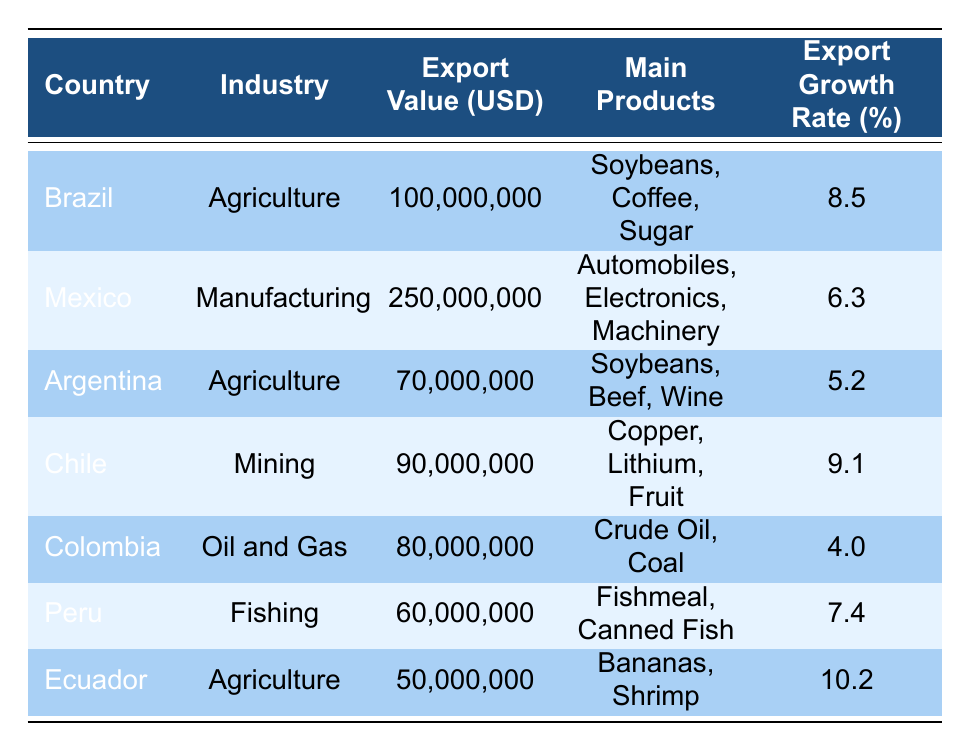What is the highest export value among the countries listed? The highest export value can be found by comparing the "Export Value (USD)" column of all countries. The highest value is 250,000,000, associated with Mexico.
Answer: 250,000,000 Which country's export growth rate is the lowest? The export growth rates are 8.5 (Brazil), 6.3 (Mexico), 5.2 (Argentina), 9.1 (Chile), 4.0 (Colombia), 7.4 (Peru), and 10.2 (Ecuador). Comparing these rates, Colombia has the lowest at 4.0%.
Answer: 4.0 What is the total export value of the Agriculture industry across all countries? To find the total export value of the Agriculture industry, we sum the export values of Brazil (100,000,000), Argentina (70,000,000), and Ecuador (50,000,000): 100,000,000 + 70,000,000 + 50,000,000 = 220,000,000.
Answer: 220,000,000 Do any countries export more than 70 million USD in Fishing industry? The table shows only Peru under the Fishing industry with an export value of 60,000,000. Since no other country exports in this industry, the answer is no.
Answer: No Which country has the most diverse range of main products listed? Analyzing the main products listed, Mexico has three diverse main products: Automobiles, Electronics, and Machinery under Manufacturing, compared to other countries which have products grouped by their industry.
Answer: Mexico 